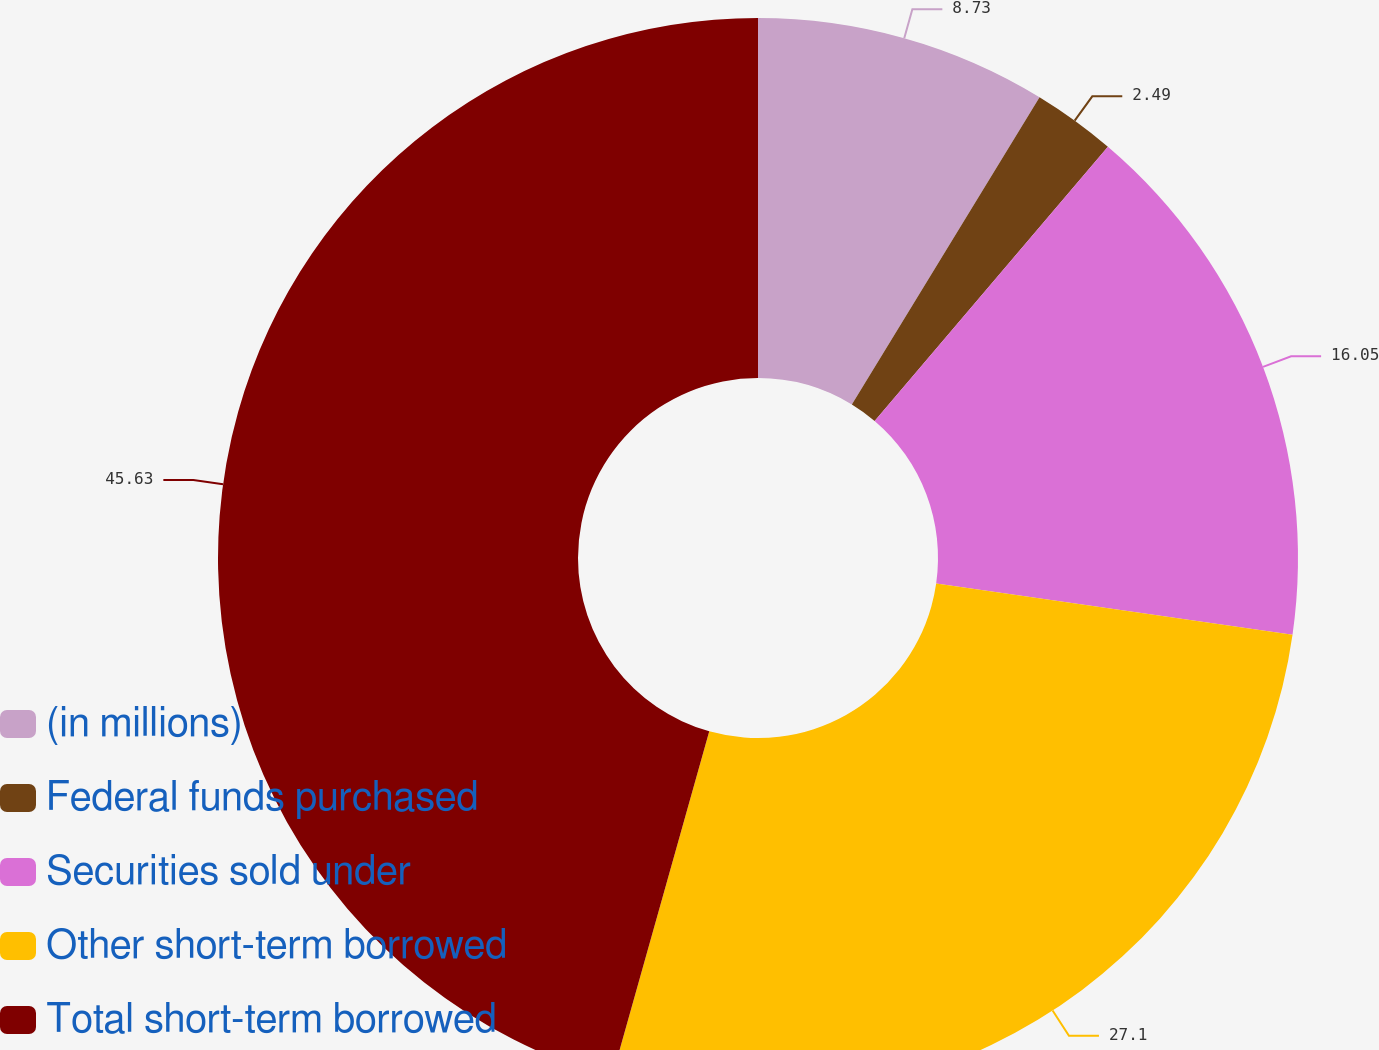Convert chart to OTSL. <chart><loc_0><loc_0><loc_500><loc_500><pie_chart><fcel>(in millions)<fcel>Federal funds purchased<fcel>Securities sold under<fcel>Other short-term borrowed<fcel>Total short-term borrowed<nl><fcel>8.73%<fcel>2.49%<fcel>16.05%<fcel>27.1%<fcel>45.64%<nl></chart> 